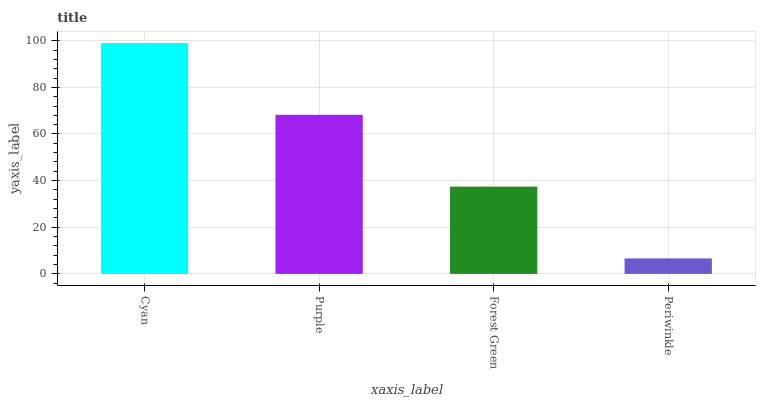Is Periwinkle the minimum?
Answer yes or no. Yes. Is Cyan the maximum?
Answer yes or no. Yes. Is Purple the minimum?
Answer yes or no. No. Is Purple the maximum?
Answer yes or no. No. Is Cyan greater than Purple?
Answer yes or no. Yes. Is Purple less than Cyan?
Answer yes or no. Yes. Is Purple greater than Cyan?
Answer yes or no. No. Is Cyan less than Purple?
Answer yes or no. No. Is Purple the high median?
Answer yes or no. Yes. Is Forest Green the low median?
Answer yes or no. Yes. Is Cyan the high median?
Answer yes or no. No. Is Cyan the low median?
Answer yes or no. No. 